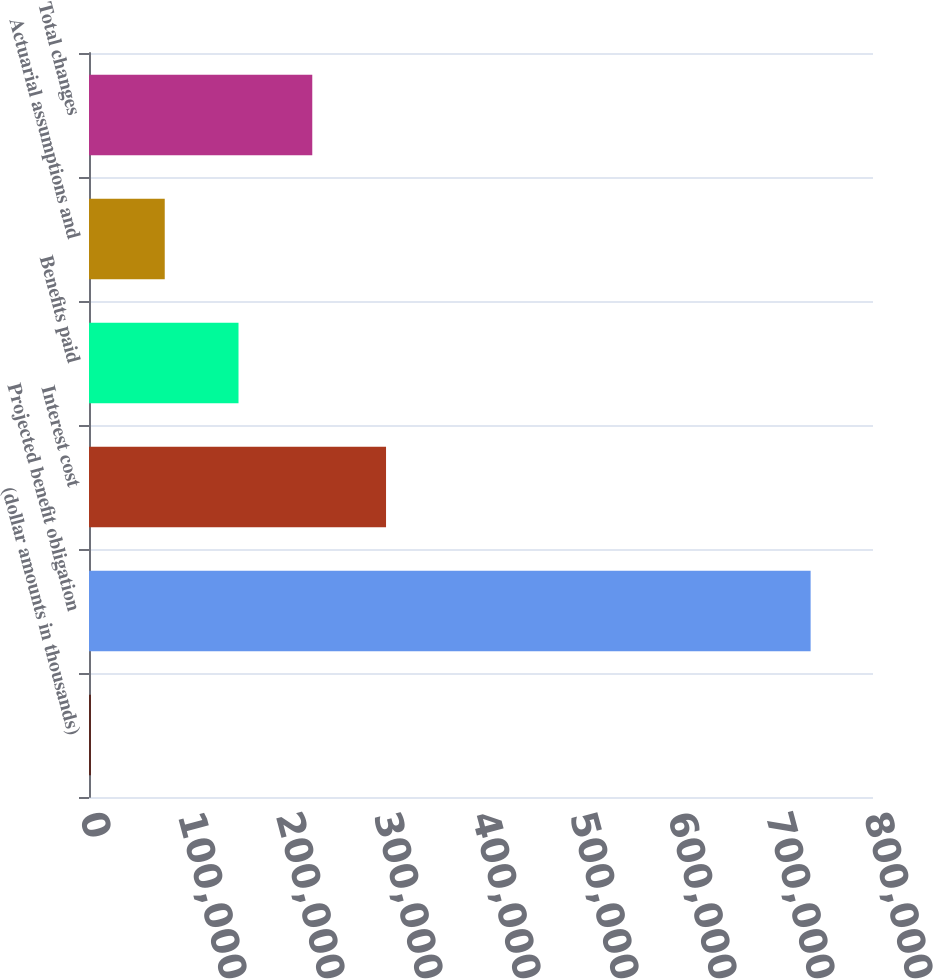<chart> <loc_0><loc_0><loc_500><loc_500><bar_chart><fcel>(dollar amounts in thousands)<fcel>Projected benefit obligation<fcel>Interest cost<fcel>Benefits paid<fcel>Actuarial assumptions and<fcel>Total changes<nl><fcel>2016<fcel>736346<fcel>303095<fcel>152556<fcel>77285.8<fcel>227825<nl></chart> 